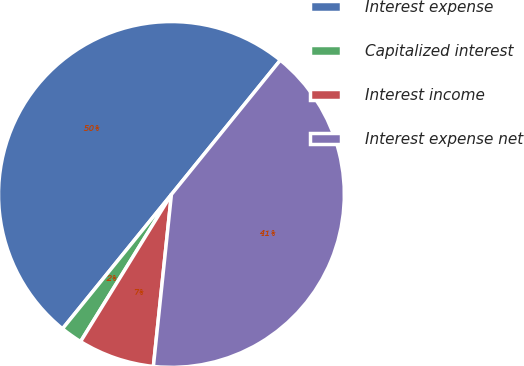<chart> <loc_0><loc_0><loc_500><loc_500><pie_chart><fcel>Interest expense<fcel>Capitalized interest<fcel>Interest income<fcel>Interest expense net<nl><fcel>50.0%<fcel>2.04%<fcel>7.14%<fcel>40.82%<nl></chart> 